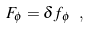<formula> <loc_0><loc_0><loc_500><loc_500>F _ { \phi } = \delta f _ { \phi } \ ,</formula> 